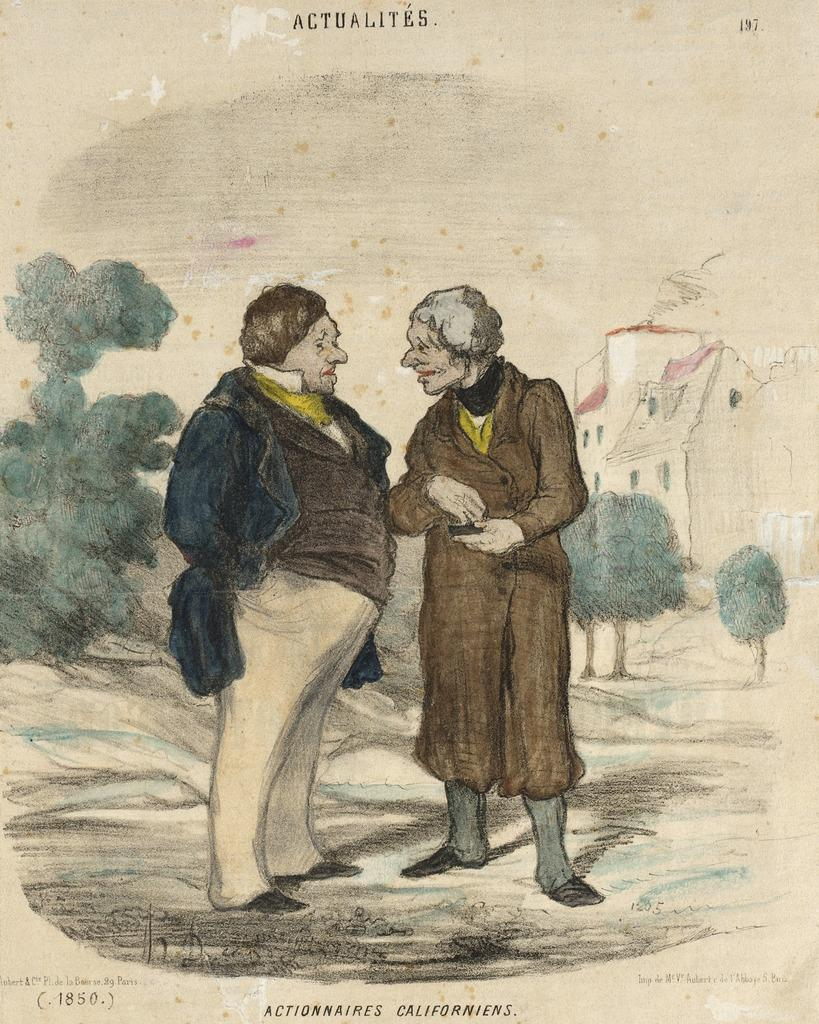What is the main subject of the image? The main subject of the image is a painting. What is happening in the painting? The painting depicts two persons standing on the ground. Are there any structures in the painting? Yes, there is a house in the painting. What type of natural elements can be seen in the painting? There are trees in the painting. What type of brass instrument is being played by the person on the left in the painting? There is no brass instrument or person playing an instrument depicted in the painting. 